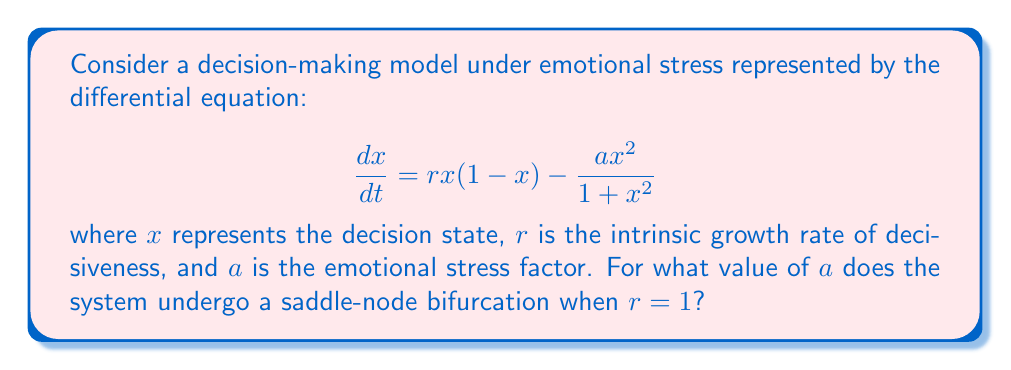Help me with this question. To find the saddle-node bifurcation point, we need to follow these steps:

1) First, find the equilibrium points by setting $\frac{dx}{dt} = 0$:

   $$rx(1-x) - \frac{ax^2}{1+x^2} = 0$$

2) Rearrange the equation:

   $$rx - rx^2 - \frac{ax^2}{1+x^2} = 0$$

3) Multiply both sides by $(1+x^2)$:

   $$rx(1+x^2) - rx^2(1+x^2) - ax^2 = 0$$

4) Expand:

   $$rx + rx^3 - rx^2 - rx^4 - ax^2 = 0$$

5) Collect terms:

   $$rx^3 - rx^4 + rx - (r+a)x^2 = 0$$

6) For a saddle-node bifurcation, this equation should have a double root. This occurs when the discriminant of the cubic equation (in $x$) is zero.

7) The general form of a cubic equation is $Ax^3 + Bx^2 + Cx + D = 0$. In our case:
   
   $A = r$, $B = -(r+a)$, $C = r$, $D = 0$

8) The discriminant of a cubic equation is given by:

   $$\Delta = 18ABCD - 4B^3D + B^2C^2 - 4AC^3 - 27A^2D^2$$

9) Substituting our values and setting $r=1$:

   $$\Delta = 18(1)(-(1+a))(1)(0) - 4(-(1+a))^3(0) + (-(1+a))^2(1)^2 - 4(1)(1)^3 - 27(1)^2(0)^2$$

10) Simplify:

    $$\Delta = (1+a)^2 - 4 = 0$$

11) Solve for $a$:

    $$a^2 + 2a - 3 = 0$$

12) Using the quadratic formula:

    $$a = \frac{-2 \pm \sqrt{4+12}}{2} = -1 \pm \sqrt{4} = -1 \pm 2$$

13) The positive solution gives the bifurcation point:

    $$a = -1 + 2 = 1$$
Answer: $a = 1$ 